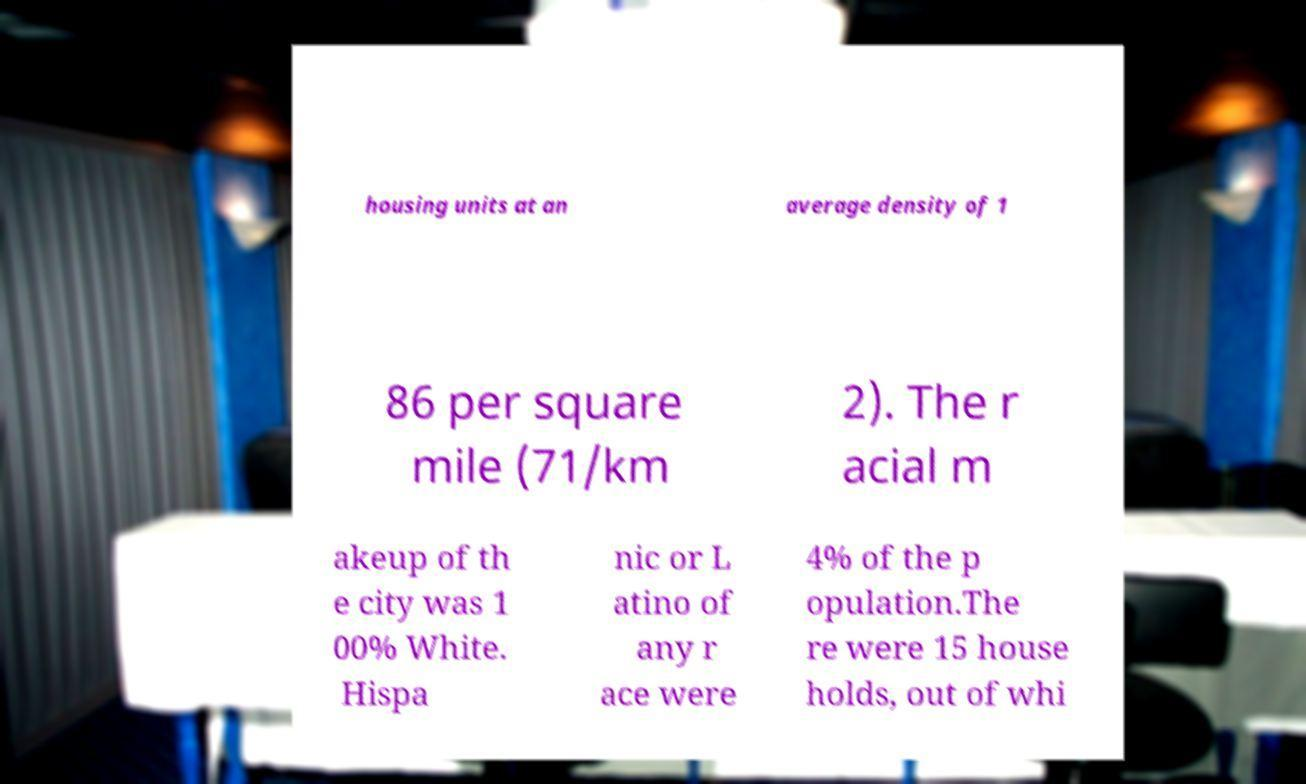Can you accurately transcribe the text from the provided image for me? housing units at an average density of 1 86 per square mile (71/km 2). The r acial m akeup of th e city was 1 00% White. Hispa nic or L atino of any r ace were 4% of the p opulation.The re were 15 house holds, out of whi 